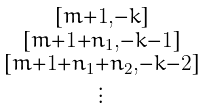Convert formula to latex. <formula><loc_0><loc_0><loc_500><loc_500>\begin{smallmatrix} [ m + 1 , - k ] \\ [ m + 1 + n _ { 1 } , - k - 1 ] \\ [ m + 1 + n _ { 1 } + n _ { 2 } , - k - 2 ] \\ \vdots \end{smallmatrix}</formula> 